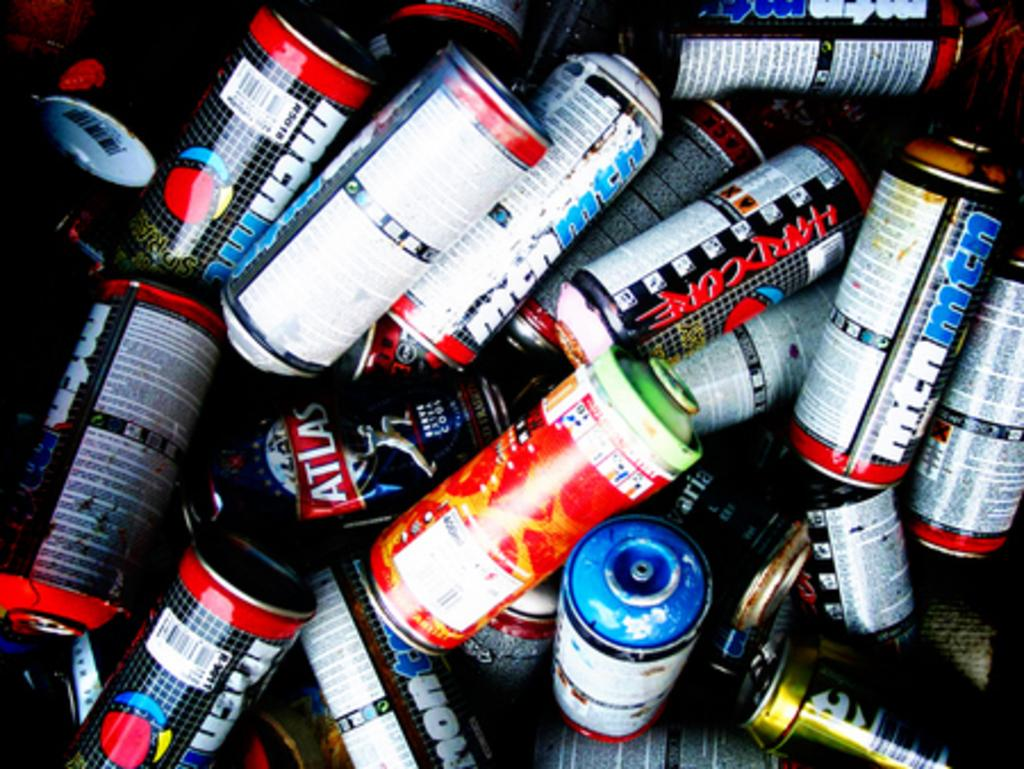<image>
Give a short and clear explanation of the subsequent image. A pile of spray paint cans, some of which say Hardocore or mtnmtn on them. 